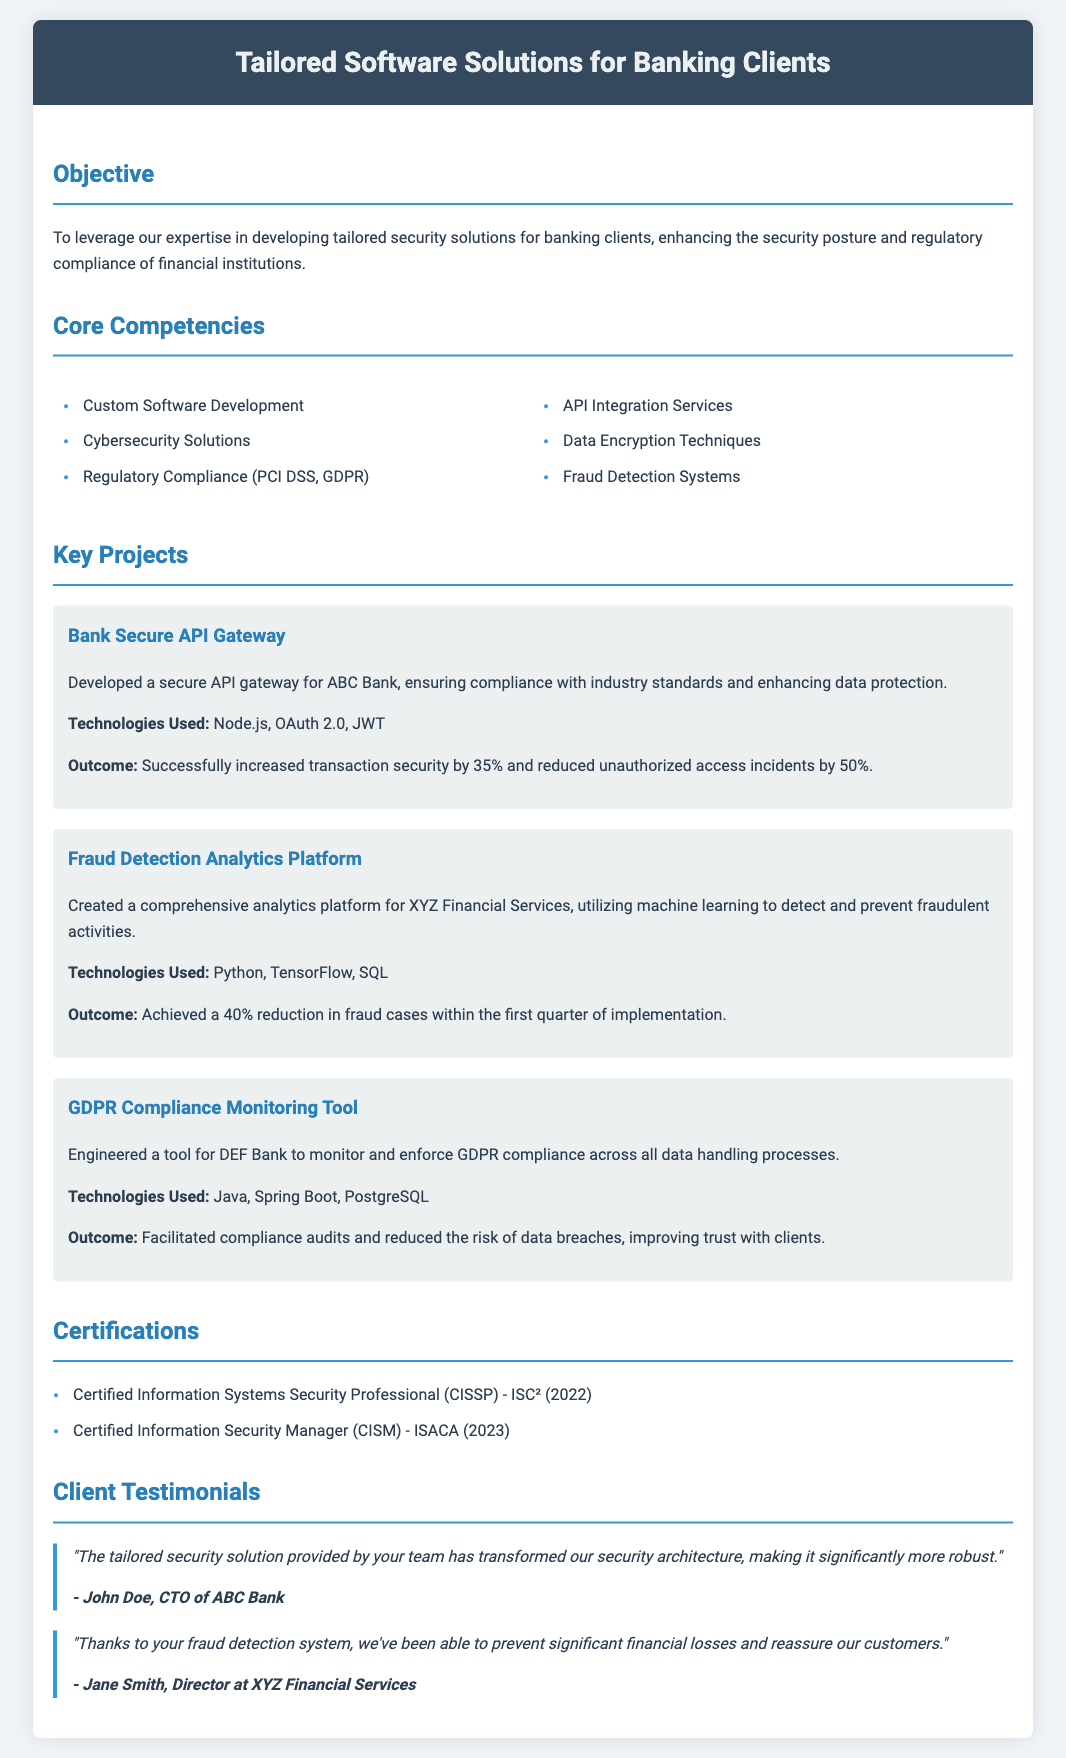What is the objective of the company? The objective is to leverage expertise in developing tailored security solutions for banking clients, enhancing security posture and regulatory compliance.
Answer: To leverage our expertise in developing tailored security solutions for banking clients, enhancing the security posture and regulatory compliance of financial institutions How many core competencies are listed? The document lists a total of six core competencies, divided into two columns.
Answer: Six What technology was used for the Fraud Detection Analytics Platform? The technology used is mentioned as Python, TensorFlow, and SQL for the Fraud Detection Analytics Platform.
Answer: Python, TensorFlow, SQL What percentage was the increase in transaction security for the Bank Secure API Gateway? The increase in transaction security is stated as 35%.
Answer: 35% Who provided a testimonial for ABC Bank? John Doe, who is the CTO of ABC Bank, provided the testimonial.
Answer: John Doe What certification was obtained in 2023? The certification obtained in 2023 is Certified Information Security Manager.
Answer: Certified Information Security Manager How many key projects are detailed in the document? There are three key projects detailed in the document.
Answer: Three What was the outcome of the GDPR Compliance Monitoring Tool? The outcome included facilitating compliance audits and reducing the risk of data breaches.
Answer: Facilitated compliance audits and reduced the risk of data breaches 